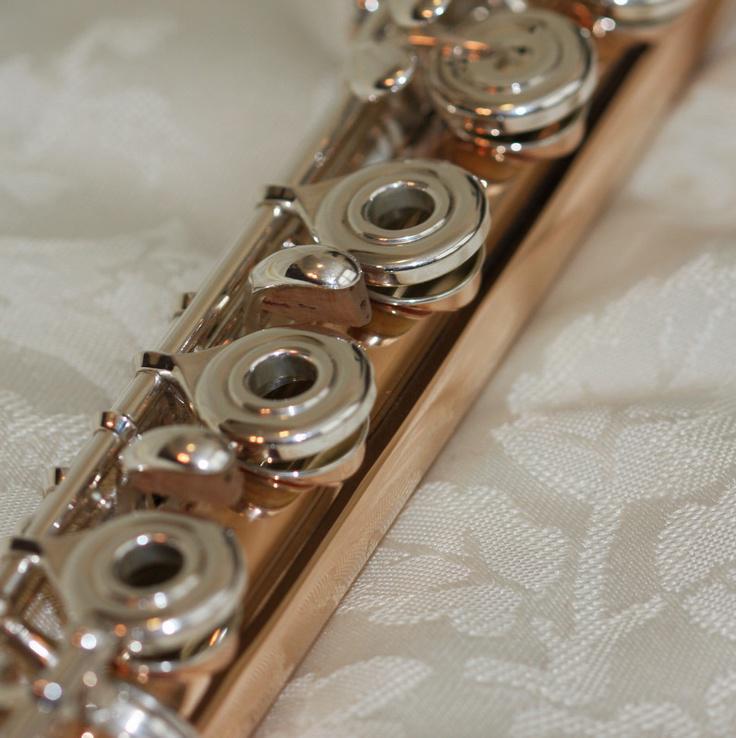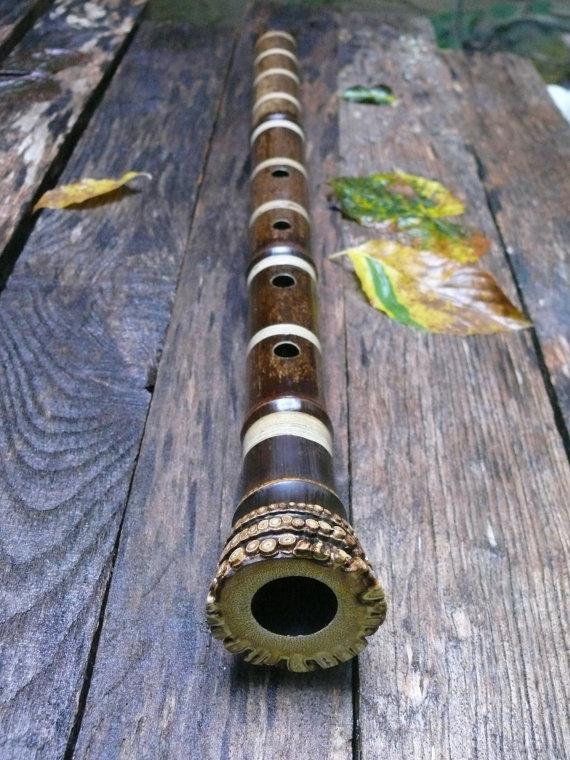The first image is the image on the left, the second image is the image on the right. Considering the images on both sides, is "there is a dark satined wood flute on a wooden table with a multicolored leaf on it" valid? Answer yes or no. Yes. 